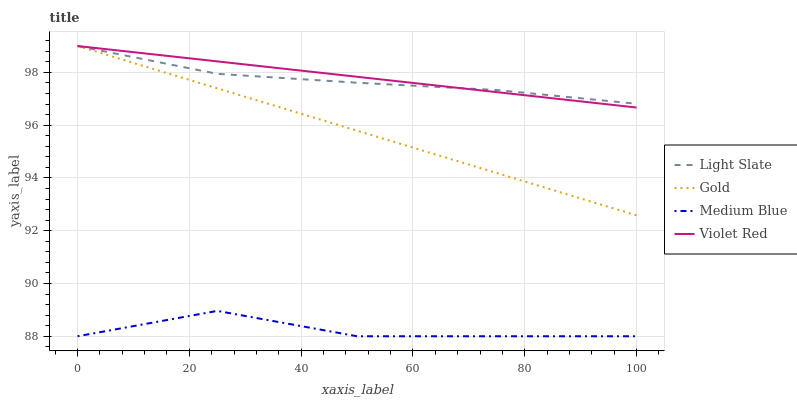Does Violet Red have the minimum area under the curve?
Answer yes or no. No. Does Medium Blue have the maximum area under the curve?
Answer yes or no. No. Is Violet Red the smoothest?
Answer yes or no. No. Is Violet Red the roughest?
Answer yes or no. No. Does Violet Red have the lowest value?
Answer yes or no. No. Does Medium Blue have the highest value?
Answer yes or no. No. Is Medium Blue less than Violet Red?
Answer yes or no. Yes. Is Light Slate greater than Medium Blue?
Answer yes or no. Yes. Does Medium Blue intersect Violet Red?
Answer yes or no. No. 